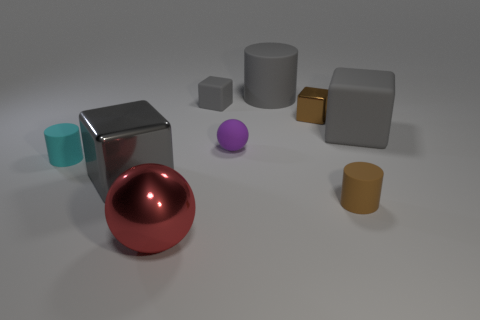What material is the cylinder that is the same color as the small shiny cube?
Offer a very short reply. Rubber. There is a tiny metal block; is it the same color as the tiny rubber object that is right of the gray cylinder?
Give a very brief answer. Yes. Is the tiny rubber block the same color as the large rubber block?
Keep it short and to the point. Yes. There is a small cube right of the rubber cylinder that is behind the small gray cube; is there a large matte thing that is left of it?
Make the answer very short. Yes. What is the shape of the large object that is behind the small brown matte object and on the left side of the tiny purple matte object?
Keep it short and to the point. Cube. Is there a big object that has the same color as the large matte cube?
Ensure brevity in your answer.  Yes. There is a large metallic object that is in front of the large gray thing that is on the left side of the purple matte object; what color is it?
Make the answer very short. Red. There is a gray matte cube that is to the right of the large gray object behind the big matte block behind the large red thing; how big is it?
Keep it short and to the point. Large. Does the tiny brown cylinder have the same material as the large gray block to the right of the tiny metal thing?
Give a very brief answer. Yes. There is a cyan cylinder that is made of the same material as the purple sphere; what is its size?
Offer a very short reply. Small. 